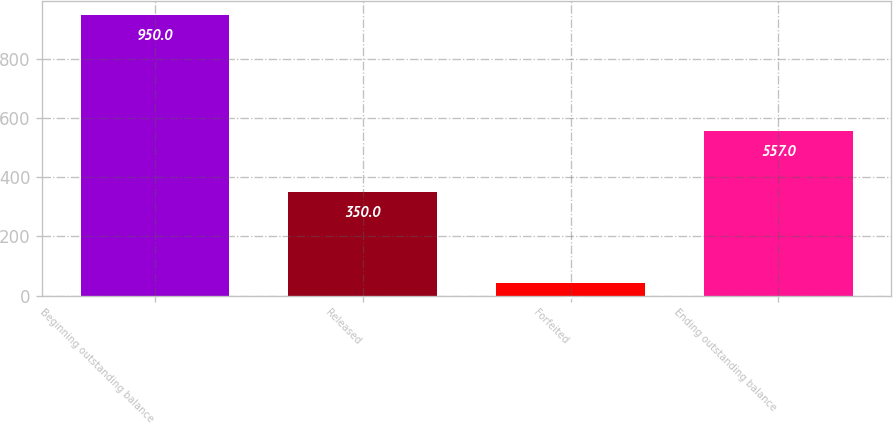Convert chart to OTSL. <chart><loc_0><loc_0><loc_500><loc_500><bar_chart><fcel>Beginning outstanding balance<fcel>Released<fcel>Forfeited<fcel>Ending outstanding balance<nl><fcel>950<fcel>350<fcel>43<fcel>557<nl></chart> 